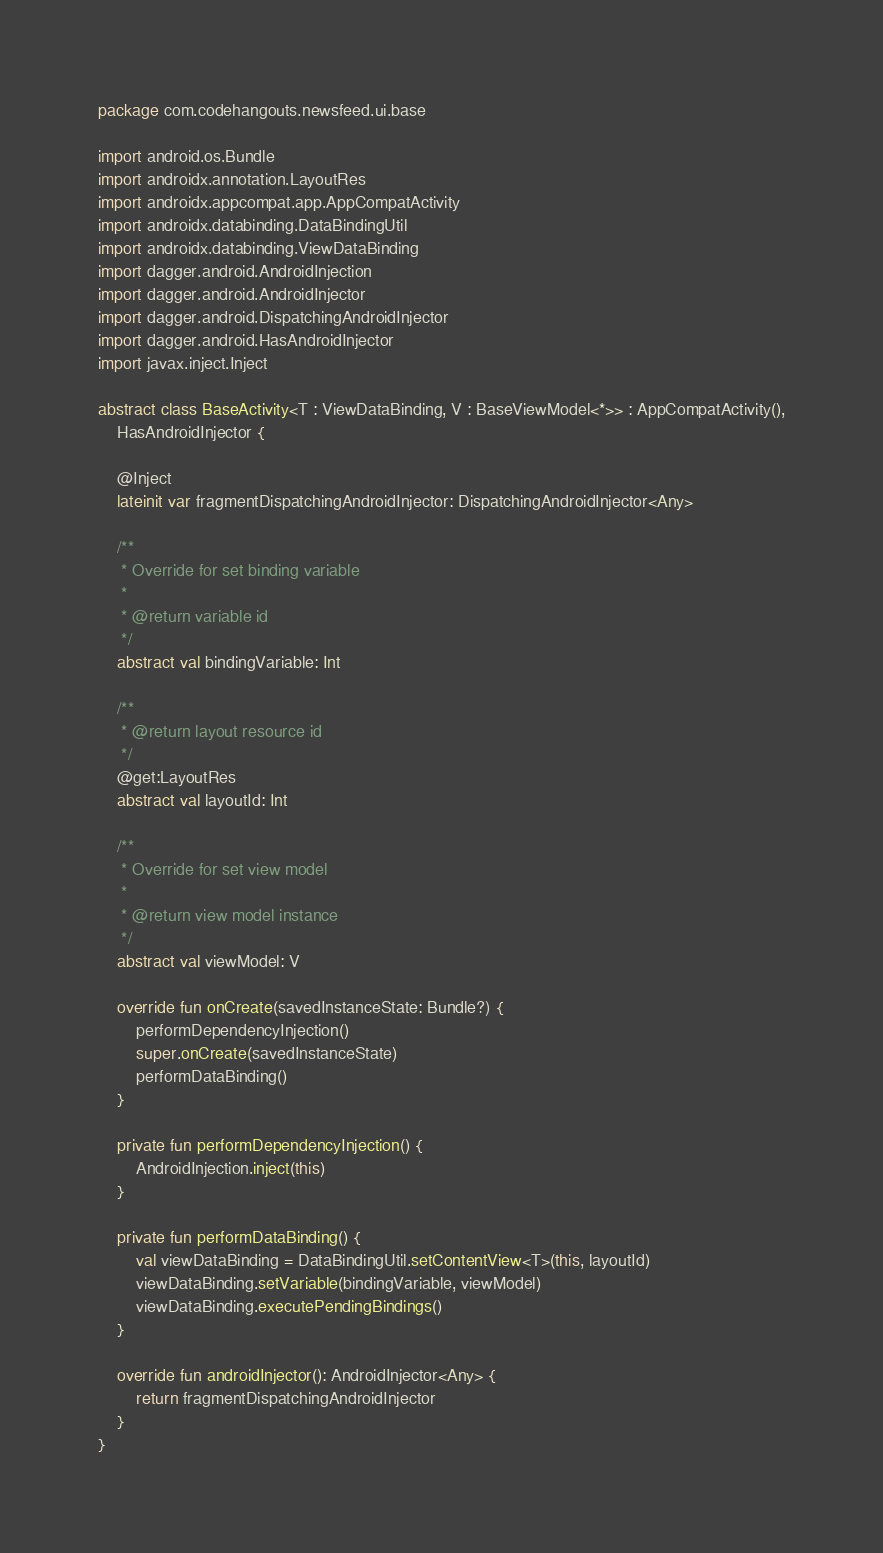<code> <loc_0><loc_0><loc_500><loc_500><_Kotlin_>package com.codehangouts.newsfeed.ui.base

import android.os.Bundle
import androidx.annotation.LayoutRes
import androidx.appcompat.app.AppCompatActivity
import androidx.databinding.DataBindingUtil
import androidx.databinding.ViewDataBinding
import dagger.android.AndroidInjection
import dagger.android.AndroidInjector
import dagger.android.DispatchingAndroidInjector
import dagger.android.HasAndroidInjector
import javax.inject.Inject

abstract class BaseActivity<T : ViewDataBinding, V : BaseViewModel<*>> : AppCompatActivity(),
    HasAndroidInjector {

    @Inject
    lateinit var fragmentDispatchingAndroidInjector: DispatchingAndroidInjector<Any>

    /**
     * Override for set binding variable
     *
     * @return variable id
     */
    abstract val bindingVariable: Int

    /**
     * @return layout resource id
     */
    @get:LayoutRes
    abstract val layoutId: Int

    /**
     * Override for set view model
     *
     * @return view model instance
     */
    abstract val viewModel: V

    override fun onCreate(savedInstanceState: Bundle?) {
        performDependencyInjection()
        super.onCreate(savedInstanceState)
        performDataBinding()
    }

    private fun performDependencyInjection() {
        AndroidInjection.inject(this)
    }

    private fun performDataBinding() {
        val viewDataBinding = DataBindingUtil.setContentView<T>(this, layoutId)
        viewDataBinding.setVariable(bindingVariable, viewModel)
        viewDataBinding.executePendingBindings()
    }

    override fun androidInjector(): AndroidInjector<Any> {
        return fragmentDispatchingAndroidInjector
    }
}</code> 